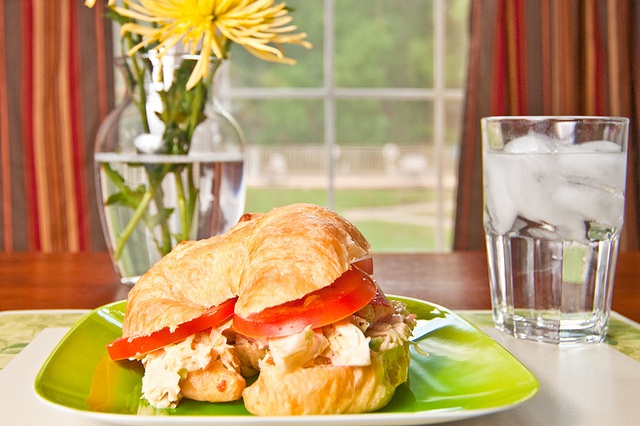Describe the objects in this image and their specific colors. I can see dining table in brown, tan, ivory, and orange tones, sandwich in brown, tan, orange, and beige tones, cup in brown, lightgray, darkgray, and gray tones, and vase in brown, lightgray, olive, and tan tones in this image. 